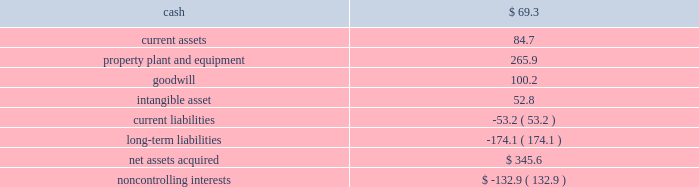Page 45 of 100 ball corporation and subsidiaries notes to consolidated financial statements 3 .
Acquisitions latapack-ball embalagens ltda .
( latapack-ball ) in august 2010 , the company paid $ 46.2 million to acquire an additional 10.1 percent economic interest in its brazilian beverage packaging joint venture , latapack-ball , through a transaction with the joint venture partner , latapack s.a .
This transaction increased the company 2019s overall economic interest in the joint venture to 60.1 percent and expands and strengthens ball 2019s presence in the growing brazilian market .
As a result of the transaction , latapack-ball became a variable interest entity ( vie ) under consolidation accounting guidelines with ball being identified as the primary beneficiary of the vie and consolidating the joint venture .
Latapack-ball operates metal beverage packaging manufacturing plants in tres rios , jacarei and salvador , brazil and has been included in the metal beverage packaging , americas and asia , reporting segment .
In connection with the acquisition , the company recorded a gain of $ 81.8 million on its previously held equity investment in latapack-ball as a result of required purchase accounting .
The table summarizes the final fair values of the latapack-ball assets acquired , liabilities assumed and non- controlling interest recognized , as well as the related investment in latapack s.a. , as of the acquisition date .
The valuation was based on market and income approaches. .
Noncontrolling interests $ ( 132.9 ) the customer relationships were identified as an intangible asset by the company and assigned an estimated life of 13.4 years .
The intangible asset is being amortized on a straight-line basis .
Neuman aluminum ( neuman ) in july 2010 , the company acquired neuman for approximately $ 62 million in cash .
Neuman had sales of approximately $ 128 million in 2009 ( unaudited ) and is the leading north american manufacturer of aluminum slugs used to make extruded aerosol cans , beverage bottles , aluminum collapsible tubes and technical impact extrusions .
Neuman operates two plants , one in the united states and one in canada , which employ approximately 180 people .
The acquisition of neuman is not material to the metal food and household products packaging , americas , segment , in which its results of operations have been included since the acquisition date .
Guangdong jianlibao group co. , ltd ( jianlibao ) in june 2010 , the company acquired jianlibao 2019s 65 percent interest in a joint venture metal beverage can and end plant in sanshui ( foshan ) , prc .
Ball has owned 35 percent of the joint venture plant since 1992 .
Ball acquired the 65 percent interest for $ 86.9 million in cash ( net of cash acquired ) and assumed debt , and also entered into a long-term supply agreement with jianlibao and one of its affiliates .
The company recorded equity earnings of $ 24.1 million , which was composed of equity earnings and a gain realized on the fair value of ball 2019s previous 35 percent equity investment as a result of required purchase accounting .
The purchase accounting was completed during the third quarter of 2010 .
The acquisition of the remaining interest is not material to the metal beverage packaging , americas and asia , segment. .
What percentage of net assets acquired was property plant and equipment? 
Computations: (265.9 / 345.6)
Answer: 0.76939. 